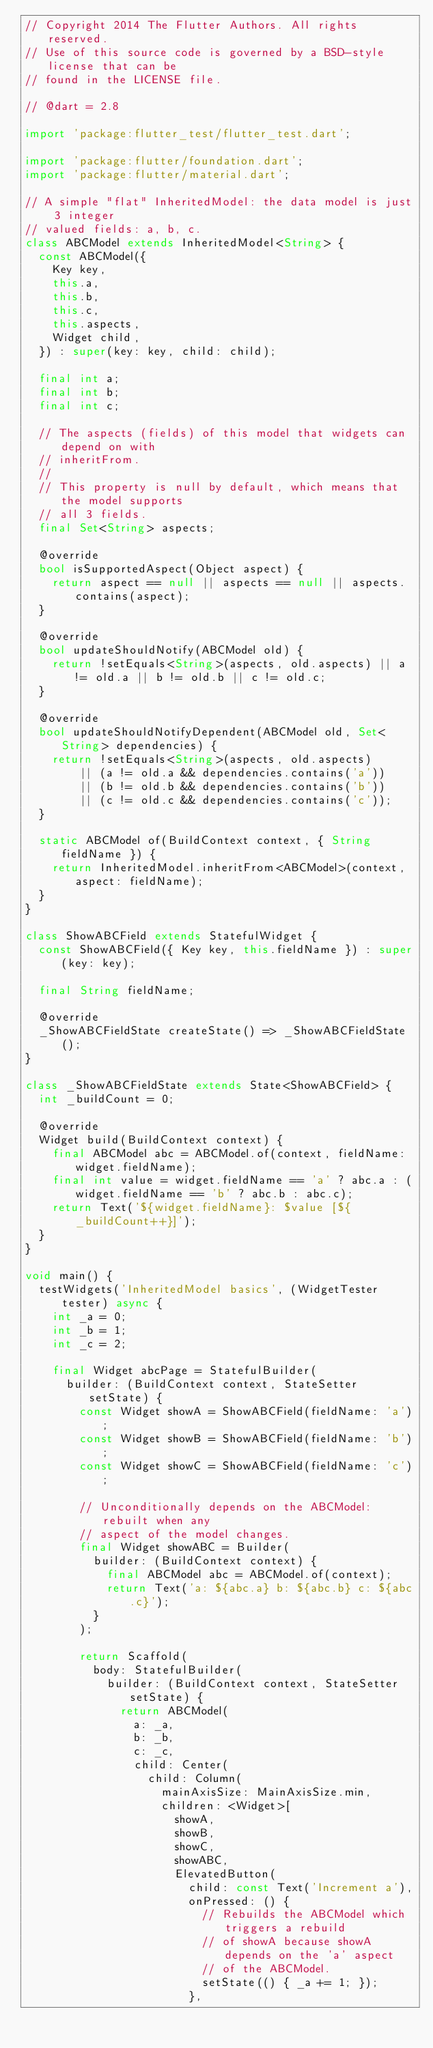<code> <loc_0><loc_0><loc_500><loc_500><_Dart_>// Copyright 2014 The Flutter Authors. All rights reserved.
// Use of this source code is governed by a BSD-style license that can be
// found in the LICENSE file.

// @dart = 2.8

import 'package:flutter_test/flutter_test.dart';

import 'package:flutter/foundation.dart';
import 'package:flutter/material.dart';

// A simple "flat" InheritedModel: the data model is just 3 integer
// valued fields: a, b, c.
class ABCModel extends InheritedModel<String> {
  const ABCModel({
    Key key,
    this.a,
    this.b,
    this.c,
    this.aspects,
    Widget child,
  }) : super(key: key, child: child);

  final int a;
  final int b;
  final int c;

  // The aspects (fields) of this model that widgets can depend on with
  // inheritFrom.
  //
  // This property is null by default, which means that the model supports
  // all 3 fields.
  final Set<String> aspects;

  @override
  bool isSupportedAspect(Object aspect) {
    return aspect == null || aspects == null || aspects.contains(aspect);
  }

  @override
  bool updateShouldNotify(ABCModel old) {
    return !setEquals<String>(aspects, old.aspects) || a != old.a || b != old.b || c != old.c;
  }

  @override
  bool updateShouldNotifyDependent(ABCModel old, Set<String> dependencies) {
    return !setEquals<String>(aspects, old.aspects)
        || (a != old.a && dependencies.contains('a'))
        || (b != old.b && dependencies.contains('b'))
        || (c != old.c && dependencies.contains('c'));
  }

  static ABCModel of(BuildContext context, { String fieldName }) {
    return InheritedModel.inheritFrom<ABCModel>(context, aspect: fieldName);
  }
}

class ShowABCField extends StatefulWidget {
  const ShowABCField({ Key key, this.fieldName }) : super(key: key);

  final String fieldName;

  @override
  _ShowABCFieldState createState() => _ShowABCFieldState();
}

class _ShowABCFieldState extends State<ShowABCField> {
  int _buildCount = 0;

  @override
  Widget build(BuildContext context) {
    final ABCModel abc = ABCModel.of(context, fieldName: widget.fieldName);
    final int value = widget.fieldName == 'a' ? abc.a : (widget.fieldName == 'b' ? abc.b : abc.c);
    return Text('${widget.fieldName}: $value [${_buildCount++}]');
  }
}

void main() {
  testWidgets('InheritedModel basics', (WidgetTester tester) async {
    int _a = 0;
    int _b = 1;
    int _c = 2;

    final Widget abcPage = StatefulBuilder(
      builder: (BuildContext context, StateSetter setState) {
        const Widget showA = ShowABCField(fieldName: 'a');
        const Widget showB = ShowABCField(fieldName: 'b');
        const Widget showC = ShowABCField(fieldName: 'c');

        // Unconditionally depends on the ABCModel: rebuilt when any
        // aspect of the model changes.
        final Widget showABC = Builder(
          builder: (BuildContext context) {
            final ABCModel abc = ABCModel.of(context);
            return Text('a: ${abc.a} b: ${abc.b} c: ${abc.c}');
          }
        );

        return Scaffold(
          body: StatefulBuilder(
            builder: (BuildContext context, StateSetter setState) {
              return ABCModel(
                a: _a,
                b: _b,
                c: _c,
                child: Center(
                  child: Column(
                    mainAxisSize: MainAxisSize.min,
                    children: <Widget>[
                      showA,
                      showB,
                      showC,
                      showABC,
                      ElevatedButton(
                        child: const Text('Increment a'),
                        onPressed: () {
                          // Rebuilds the ABCModel which triggers a rebuild
                          // of showA because showA depends on the 'a' aspect
                          // of the ABCModel.
                          setState(() { _a += 1; });
                        },</code> 